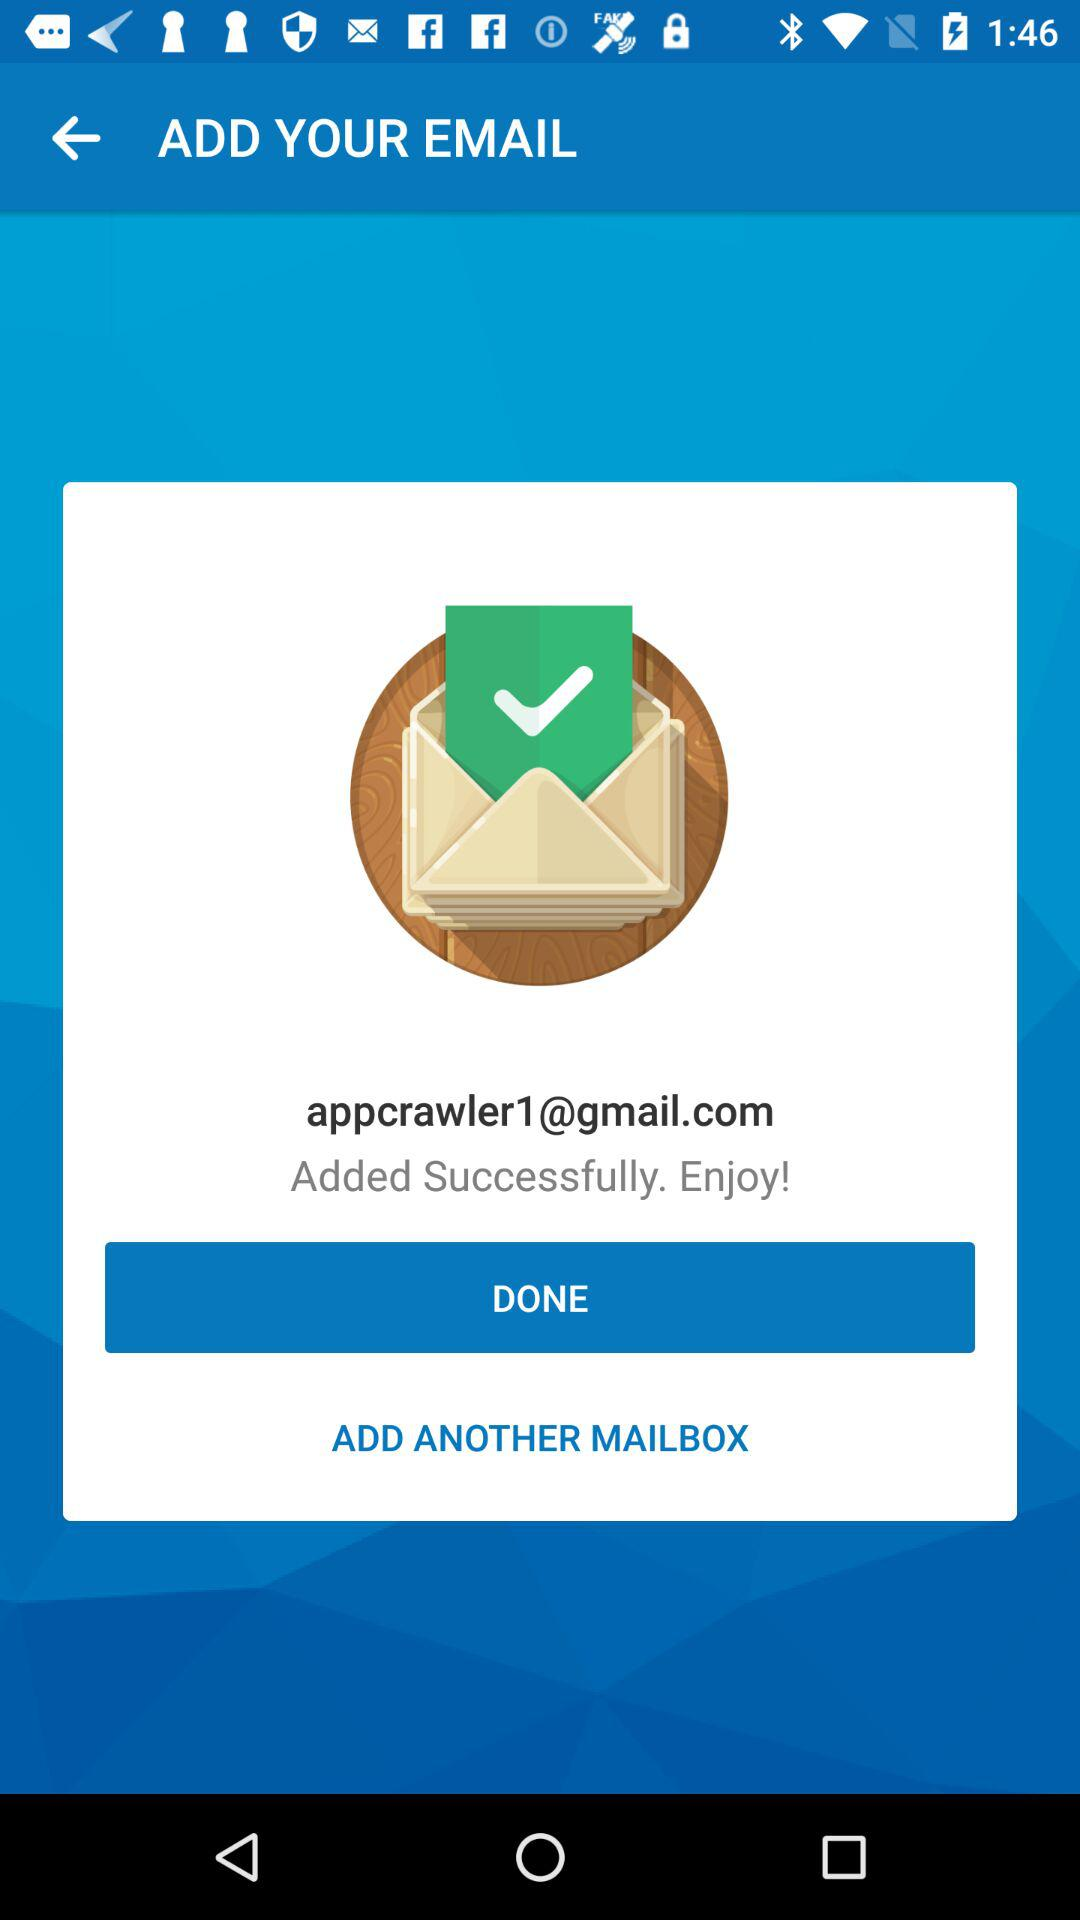What is the email address? The email address is appcrawler1@gmail.com. 